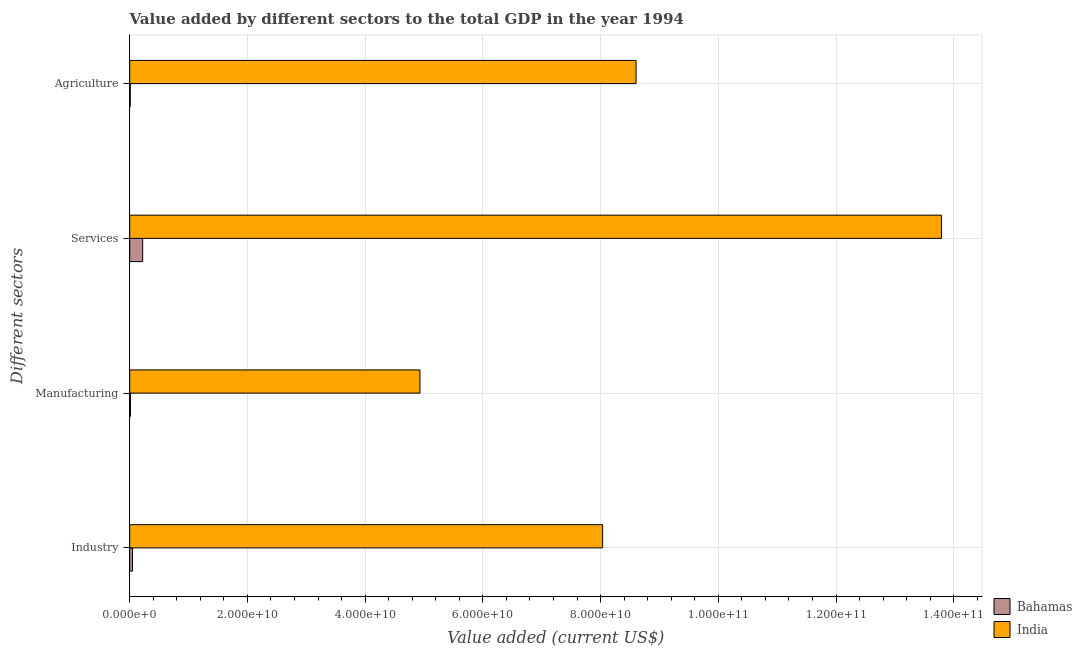How many different coloured bars are there?
Provide a succinct answer. 2. Are the number of bars per tick equal to the number of legend labels?
Provide a short and direct response. Yes. How many bars are there on the 4th tick from the top?
Ensure brevity in your answer.  2. How many bars are there on the 2nd tick from the bottom?
Offer a terse response. 2. What is the label of the 3rd group of bars from the top?
Give a very brief answer. Manufacturing. What is the value added by industrial sector in India?
Provide a short and direct response. 8.03e+1. Across all countries, what is the maximum value added by services sector?
Give a very brief answer. 1.38e+11. Across all countries, what is the minimum value added by services sector?
Keep it short and to the point. 2.20e+09. In which country was the value added by agricultural sector maximum?
Your response must be concise. India. In which country was the value added by services sector minimum?
Provide a succinct answer. Bahamas. What is the total value added by agricultural sector in the graph?
Your answer should be compact. 8.61e+1. What is the difference between the value added by agricultural sector in India and that in Bahamas?
Give a very brief answer. 8.59e+1. What is the difference between the value added by manufacturing sector in India and the value added by agricultural sector in Bahamas?
Make the answer very short. 4.92e+1. What is the average value added by agricultural sector per country?
Offer a terse response. 4.31e+1. What is the difference between the value added by services sector and value added by agricultural sector in India?
Make the answer very short. 5.19e+1. What is the ratio of the value added by services sector in Bahamas to that in India?
Offer a very short reply. 0.02. Is the value added by services sector in Bahamas less than that in India?
Give a very brief answer. Yes. Is the difference between the value added by industrial sector in Bahamas and India greater than the difference between the value added by manufacturing sector in Bahamas and India?
Your answer should be very brief. No. What is the difference between the highest and the second highest value added by industrial sector?
Your response must be concise. 7.99e+1. What is the difference between the highest and the lowest value added by services sector?
Your response must be concise. 1.36e+11. In how many countries, is the value added by manufacturing sector greater than the average value added by manufacturing sector taken over all countries?
Your answer should be very brief. 1. What does the 1st bar from the bottom in Agriculture represents?
Provide a short and direct response. Bahamas. Is it the case that in every country, the sum of the value added by industrial sector and value added by manufacturing sector is greater than the value added by services sector?
Your answer should be compact. No. What is the difference between two consecutive major ticks on the X-axis?
Give a very brief answer. 2.00e+1. What is the title of the graph?
Provide a short and direct response. Value added by different sectors to the total GDP in the year 1994. What is the label or title of the X-axis?
Keep it short and to the point. Value added (current US$). What is the label or title of the Y-axis?
Your answer should be compact. Different sectors. What is the Value added (current US$) in Bahamas in Industry?
Your answer should be very brief. 4.75e+08. What is the Value added (current US$) of India in Industry?
Your answer should be very brief. 8.03e+1. What is the Value added (current US$) of Bahamas in Manufacturing?
Your answer should be very brief. 1.34e+08. What is the Value added (current US$) in India in Manufacturing?
Your answer should be compact. 4.93e+1. What is the Value added (current US$) of Bahamas in Services?
Your response must be concise. 2.20e+09. What is the Value added (current US$) of India in Services?
Ensure brevity in your answer.  1.38e+11. What is the Value added (current US$) in Bahamas in Agriculture?
Keep it short and to the point. 8.72e+07. What is the Value added (current US$) in India in Agriculture?
Provide a succinct answer. 8.60e+1. Across all Different sectors, what is the maximum Value added (current US$) of Bahamas?
Your answer should be very brief. 2.20e+09. Across all Different sectors, what is the maximum Value added (current US$) of India?
Provide a succinct answer. 1.38e+11. Across all Different sectors, what is the minimum Value added (current US$) of Bahamas?
Give a very brief answer. 8.72e+07. Across all Different sectors, what is the minimum Value added (current US$) of India?
Your answer should be very brief. 4.93e+1. What is the total Value added (current US$) of Bahamas in the graph?
Your response must be concise. 2.90e+09. What is the total Value added (current US$) of India in the graph?
Provide a short and direct response. 3.54e+11. What is the difference between the Value added (current US$) of Bahamas in Industry and that in Manufacturing?
Your answer should be compact. 3.41e+08. What is the difference between the Value added (current US$) in India in Industry and that in Manufacturing?
Your answer should be compact. 3.10e+1. What is the difference between the Value added (current US$) in Bahamas in Industry and that in Services?
Offer a terse response. -1.72e+09. What is the difference between the Value added (current US$) of India in Industry and that in Services?
Make the answer very short. -5.76e+1. What is the difference between the Value added (current US$) in Bahamas in Industry and that in Agriculture?
Offer a very short reply. 3.88e+08. What is the difference between the Value added (current US$) in India in Industry and that in Agriculture?
Ensure brevity in your answer.  -5.68e+09. What is the difference between the Value added (current US$) in Bahamas in Manufacturing and that in Services?
Offer a terse response. -2.06e+09. What is the difference between the Value added (current US$) in India in Manufacturing and that in Services?
Your answer should be compact. -8.86e+1. What is the difference between the Value added (current US$) of Bahamas in Manufacturing and that in Agriculture?
Ensure brevity in your answer.  4.68e+07. What is the difference between the Value added (current US$) of India in Manufacturing and that in Agriculture?
Offer a terse response. -3.67e+1. What is the difference between the Value added (current US$) of Bahamas in Services and that in Agriculture?
Provide a short and direct response. 2.11e+09. What is the difference between the Value added (current US$) of India in Services and that in Agriculture?
Offer a very short reply. 5.19e+1. What is the difference between the Value added (current US$) of Bahamas in Industry and the Value added (current US$) of India in Manufacturing?
Your response must be concise. -4.88e+1. What is the difference between the Value added (current US$) of Bahamas in Industry and the Value added (current US$) of India in Services?
Make the answer very short. -1.37e+11. What is the difference between the Value added (current US$) in Bahamas in Industry and the Value added (current US$) in India in Agriculture?
Provide a succinct answer. -8.56e+1. What is the difference between the Value added (current US$) of Bahamas in Manufacturing and the Value added (current US$) of India in Services?
Your response must be concise. -1.38e+11. What is the difference between the Value added (current US$) of Bahamas in Manufacturing and the Value added (current US$) of India in Agriculture?
Provide a succinct answer. -8.59e+1. What is the difference between the Value added (current US$) of Bahamas in Services and the Value added (current US$) of India in Agriculture?
Provide a short and direct response. -8.38e+1. What is the average Value added (current US$) of Bahamas per Different sectors?
Your response must be concise. 7.24e+08. What is the average Value added (current US$) in India per Different sectors?
Your response must be concise. 8.84e+1. What is the difference between the Value added (current US$) in Bahamas and Value added (current US$) in India in Industry?
Your response must be concise. -7.99e+1. What is the difference between the Value added (current US$) in Bahamas and Value added (current US$) in India in Manufacturing?
Your answer should be compact. -4.92e+1. What is the difference between the Value added (current US$) in Bahamas and Value added (current US$) in India in Services?
Offer a terse response. -1.36e+11. What is the difference between the Value added (current US$) in Bahamas and Value added (current US$) in India in Agriculture?
Ensure brevity in your answer.  -8.59e+1. What is the ratio of the Value added (current US$) of Bahamas in Industry to that in Manufacturing?
Keep it short and to the point. 3.55. What is the ratio of the Value added (current US$) of India in Industry to that in Manufacturing?
Keep it short and to the point. 1.63. What is the ratio of the Value added (current US$) in Bahamas in Industry to that in Services?
Give a very brief answer. 0.22. What is the ratio of the Value added (current US$) of India in Industry to that in Services?
Offer a very short reply. 0.58. What is the ratio of the Value added (current US$) in Bahamas in Industry to that in Agriculture?
Keep it short and to the point. 5.45. What is the ratio of the Value added (current US$) in India in Industry to that in Agriculture?
Make the answer very short. 0.93. What is the ratio of the Value added (current US$) of Bahamas in Manufacturing to that in Services?
Offer a very short reply. 0.06. What is the ratio of the Value added (current US$) in India in Manufacturing to that in Services?
Keep it short and to the point. 0.36. What is the ratio of the Value added (current US$) of Bahamas in Manufacturing to that in Agriculture?
Your answer should be compact. 1.54. What is the ratio of the Value added (current US$) in India in Manufacturing to that in Agriculture?
Give a very brief answer. 0.57. What is the ratio of the Value added (current US$) of Bahamas in Services to that in Agriculture?
Provide a short and direct response. 25.22. What is the ratio of the Value added (current US$) of India in Services to that in Agriculture?
Offer a very short reply. 1.6. What is the difference between the highest and the second highest Value added (current US$) in Bahamas?
Provide a short and direct response. 1.72e+09. What is the difference between the highest and the second highest Value added (current US$) of India?
Your answer should be very brief. 5.19e+1. What is the difference between the highest and the lowest Value added (current US$) in Bahamas?
Your answer should be compact. 2.11e+09. What is the difference between the highest and the lowest Value added (current US$) of India?
Your answer should be very brief. 8.86e+1. 